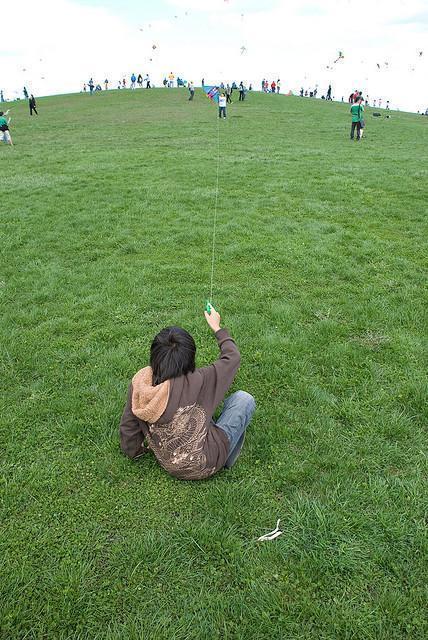What is the boy sitting in the grass doing?
Indicate the correct choice and explain in the format: 'Answer: answer
Rationale: rationale.'
Options: Playing pokemon, resting, texting, flying kite. Answer: flying kite.
Rationale: He is holding the string to his kite that is in the air. 